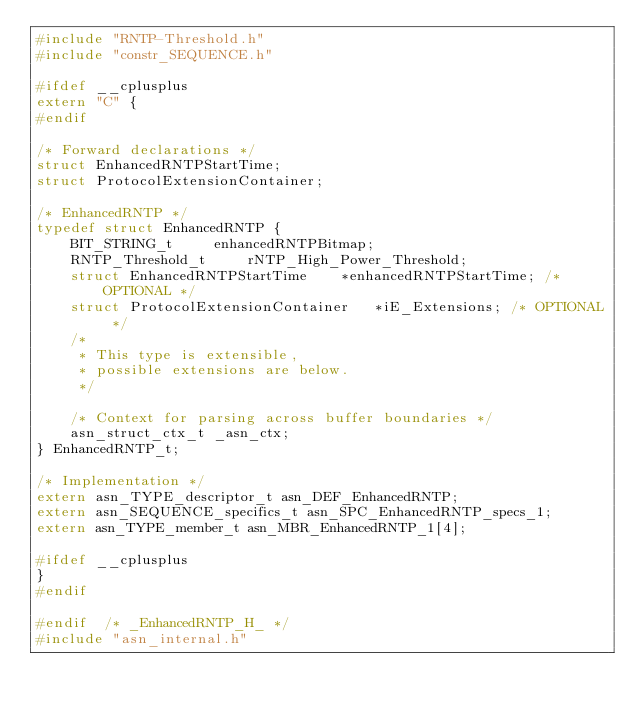<code> <loc_0><loc_0><loc_500><loc_500><_C_>#include "RNTP-Threshold.h"
#include "constr_SEQUENCE.h"

#ifdef __cplusplus
extern "C" {
#endif

/* Forward declarations */
struct EnhancedRNTPStartTime;
struct ProtocolExtensionContainer;

/* EnhancedRNTP */
typedef struct EnhancedRNTP {
	BIT_STRING_t	 enhancedRNTPBitmap;
	RNTP_Threshold_t	 rNTP_High_Power_Threshold;
	struct EnhancedRNTPStartTime	*enhancedRNTPStartTime;	/* OPTIONAL */
	struct ProtocolExtensionContainer	*iE_Extensions;	/* OPTIONAL */
	/*
	 * This type is extensible,
	 * possible extensions are below.
	 */
	
	/* Context for parsing across buffer boundaries */
	asn_struct_ctx_t _asn_ctx;
} EnhancedRNTP_t;

/* Implementation */
extern asn_TYPE_descriptor_t asn_DEF_EnhancedRNTP;
extern asn_SEQUENCE_specifics_t asn_SPC_EnhancedRNTP_specs_1;
extern asn_TYPE_member_t asn_MBR_EnhancedRNTP_1[4];

#ifdef __cplusplus
}
#endif

#endif	/* _EnhancedRNTP_H_ */
#include "asn_internal.h"
</code> 